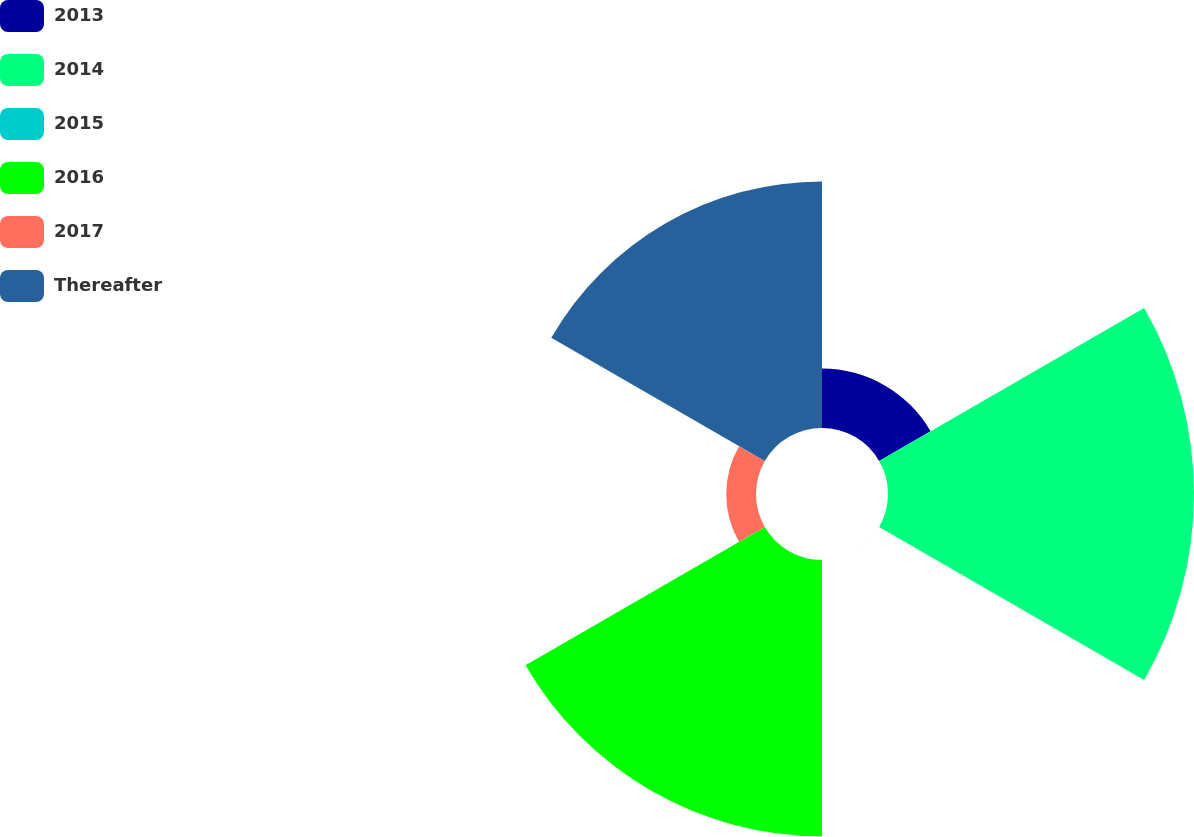Convert chart. <chart><loc_0><loc_0><loc_500><loc_500><pie_chart><fcel>2013<fcel>2014<fcel>2015<fcel>2016<fcel>2017<fcel>Thereafter<nl><fcel>6.47%<fcel>33.33%<fcel>0.01%<fcel>30.1%<fcel>3.24%<fcel>26.86%<nl></chart> 